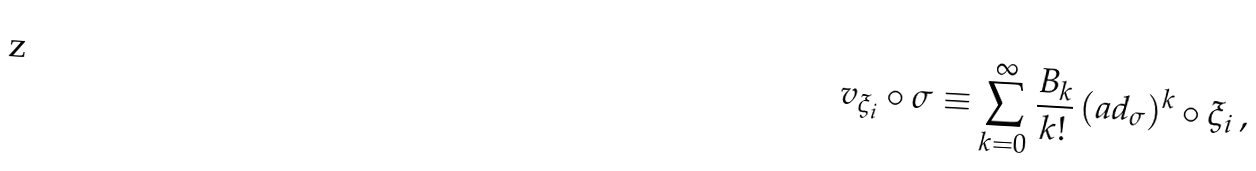<formula> <loc_0><loc_0><loc_500><loc_500>v _ { \xi _ { i } } \circ \sigma \equiv \sum _ { k = 0 } ^ { \infty } \frac { B _ { k } } { k ! } \, ( a d _ { \sigma } ) ^ { k } \circ \xi _ { i } \, ,</formula> 